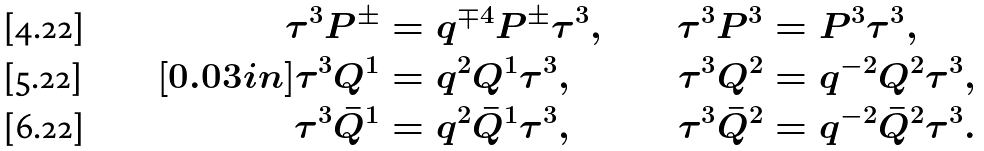<formula> <loc_0><loc_0><loc_500><loc_500>\tau ^ { 3 } P ^ { \pm } & = q ^ { \mp 4 } P ^ { \pm } \tau ^ { 3 } , & \tau ^ { 3 } P ^ { 3 } & = P ^ { 3 } \tau ^ { 3 } , \\ [ 0 . 0 3 i n ] \tau ^ { 3 } Q ^ { 1 } & = q ^ { 2 } Q ^ { 1 } \tau ^ { 3 } , & \tau ^ { 3 } Q ^ { 2 } & = q ^ { - 2 } Q ^ { 2 } \tau ^ { 3 } , \\ \tau ^ { 3 } \bar { Q } ^ { 1 } & = q ^ { 2 } \bar { Q } ^ { 1 } \tau ^ { 3 } , & \tau ^ { 3 } \bar { Q } ^ { 2 } & = q ^ { - 2 } \bar { Q } ^ { 2 } \tau ^ { 3 } .</formula> 